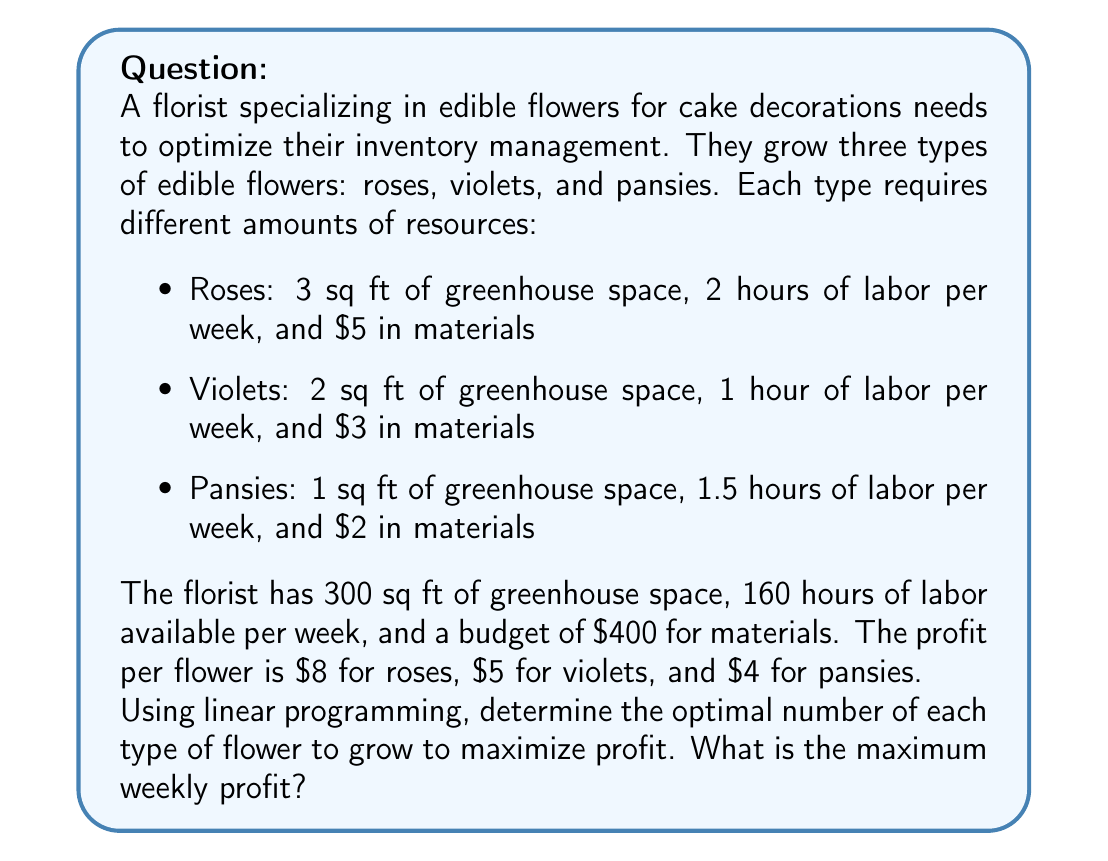What is the answer to this math problem? To solve this problem using linear programming, we need to follow these steps:

1. Define the decision variables:
Let $x_1$, $x_2$, and $x_3$ represent the number of roses, violets, and pansies to grow, respectively.

2. Formulate the objective function:
Maximize profit: $Z = 8x_1 + 5x_2 + 4x_3$

3. Identify the constraints:
   a) Greenhouse space: $3x_1 + 2x_2 + x_3 \leq 300$
   b) Labor: $2x_1 + x_2 + 1.5x_3 \leq 160$
   c) Materials budget: $5x_1 + 3x_2 + 2x_3 \leq 400$
   d) Non-negativity: $x_1, x_2, x_3 \geq 0$

4. Solve the linear programming problem:
We can solve this problem using the simplex method or a linear programming solver. For this explanation, we'll use the graphical method since we have only three variables.

5. Solve the system of equations for each pair of constraints:
   a) Greenhouse and Labor:
      $3x_1 + 2x_2 + x_3 = 300$
      $2x_1 + x_2 + 1.5x_3 = 160$
      Solving these equations gives us the point (40, 90, 0).

   b) Greenhouse and Materials:
      $3x_1 + 2x_2 + x_3 = 300$
      $5x_1 + 3x_2 + 2x_3 = 400$
      Solving these equations gives us the point (20, 120, 0).

   c) Labor and Materials:
      $2x_1 + x_2 + 1.5x_3 = 160$
      $5x_1 + 3x_2 + 2x_3 = 400$
      Solving these equations gives us the point (50, 60, 0).

6. Evaluate the objective function at each feasible point:
   (40, 90, 0): $Z = 8(40) + 5(90) + 4(0) = 770$
   (20, 120, 0): $Z = 8(20) + 5(120) + 4(0) = 760$
   (50, 60, 0): $Z = 8(50) + 5(60) + 4(0) = 700$

7. Identify the optimal solution:
The point (40, 90, 0) gives the maximum profit of $770.
Answer: The optimal solution is to grow 40 roses and 90 violets, with no pansies. The maximum weekly profit is $770. 